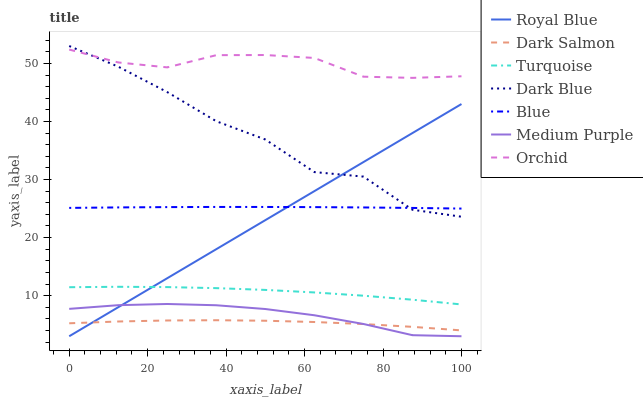Does Turquoise have the minimum area under the curve?
Answer yes or no. No. Does Turquoise have the maximum area under the curve?
Answer yes or no. No. Is Turquoise the smoothest?
Answer yes or no. No. Is Turquoise the roughest?
Answer yes or no. No. Does Turquoise have the lowest value?
Answer yes or no. No. Does Turquoise have the highest value?
Answer yes or no. No. Is Dark Salmon less than Orchid?
Answer yes or no. Yes. Is Turquoise greater than Dark Salmon?
Answer yes or no. Yes. Does Dark Salmon intersect Orchid?
Answer yes or no. No. 